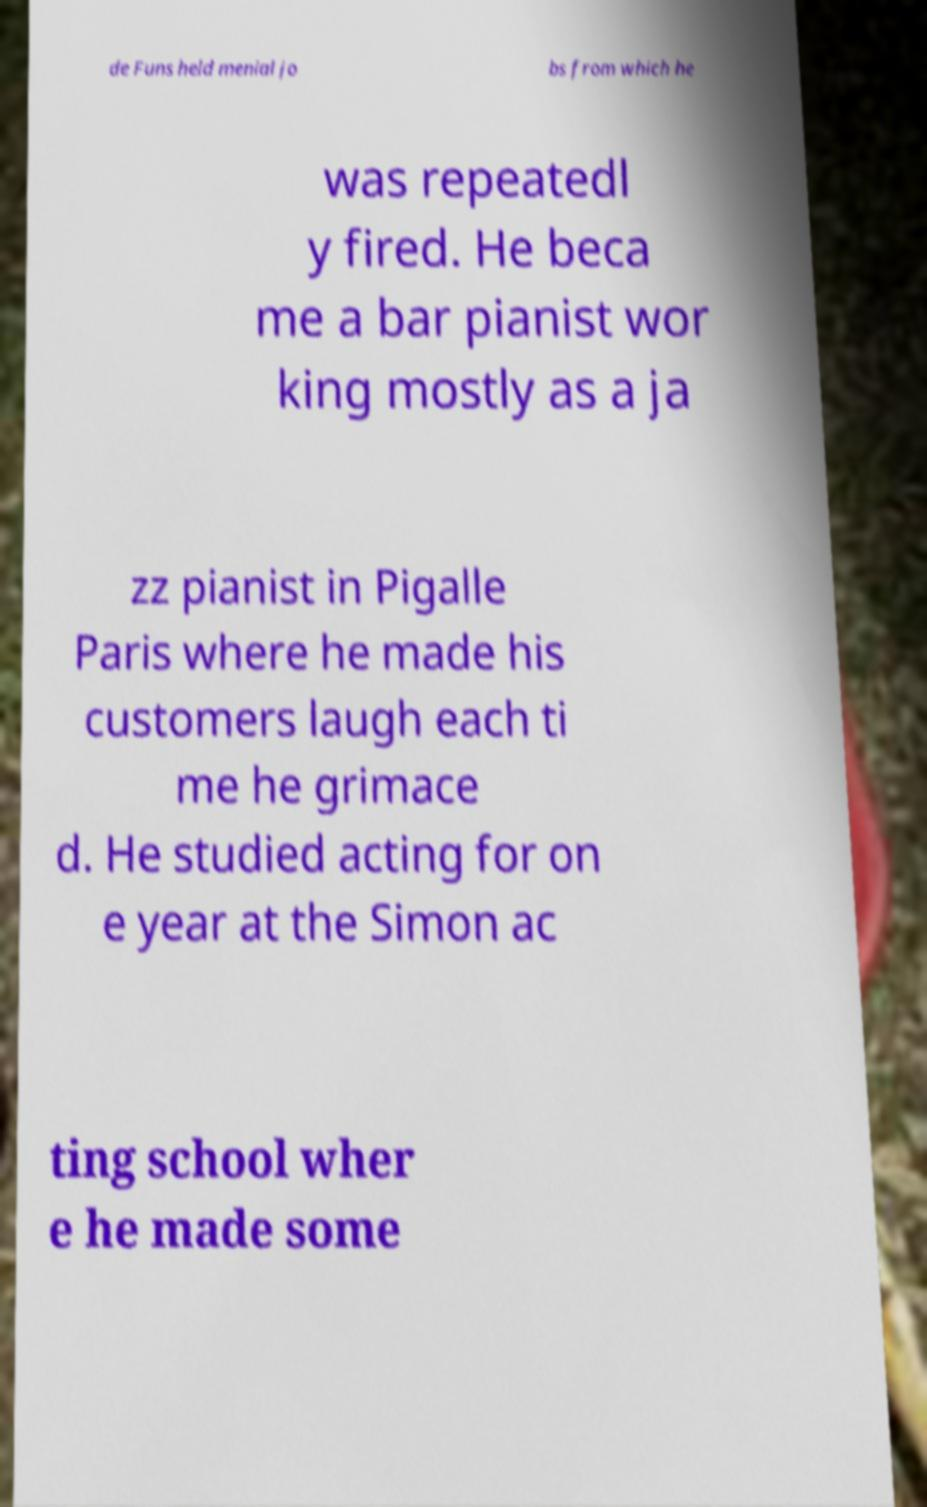I need the written content from this picture converted into text. Can you do that? de Funs held menial jo bs from which he was repeatedl y fired. He beca me a bar pianist wor king mostly as a ja zz pianist in Pigalle Paris where he made his customers laugh each ti me he grimace d. He studied acting for on e year at the Simon ac ting school wher e he made some 